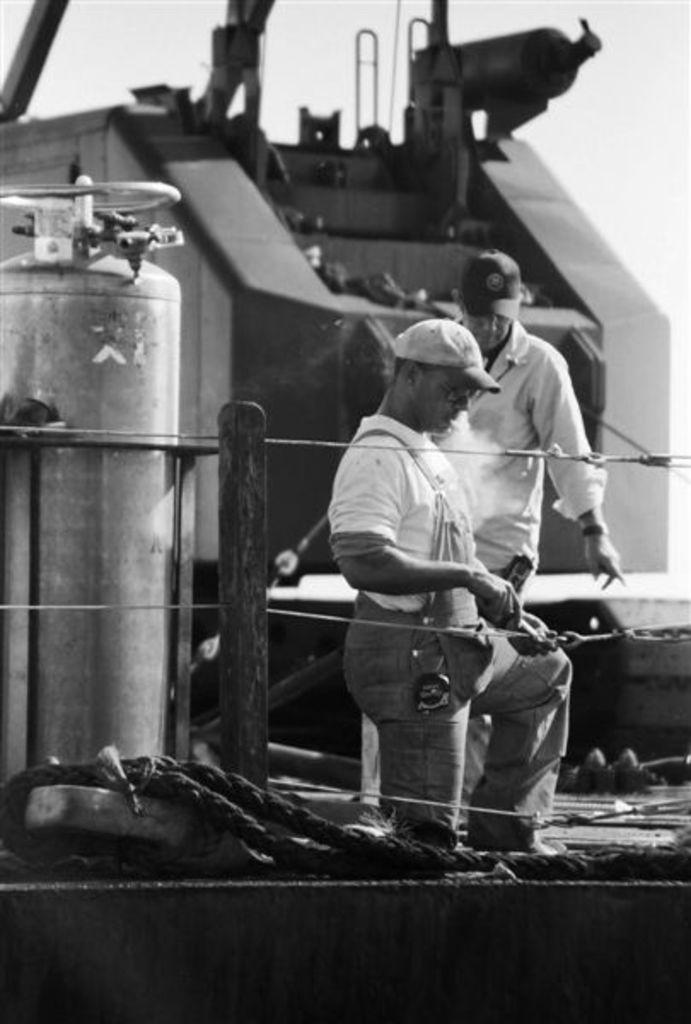What is the color scheme of the image? The image is black and white. How many people are in the image? There are 2 people in the image. What are the people wearing on their heads? The people are wearing caps. What object can be seen on the left side of the image? There is a cylinder on the left side of the image. Can you describe the bee buzzing around the people in the image? There is no bee present in the image; it is a black and white image featuring two people wearing caps and a cylinder on the left side. 